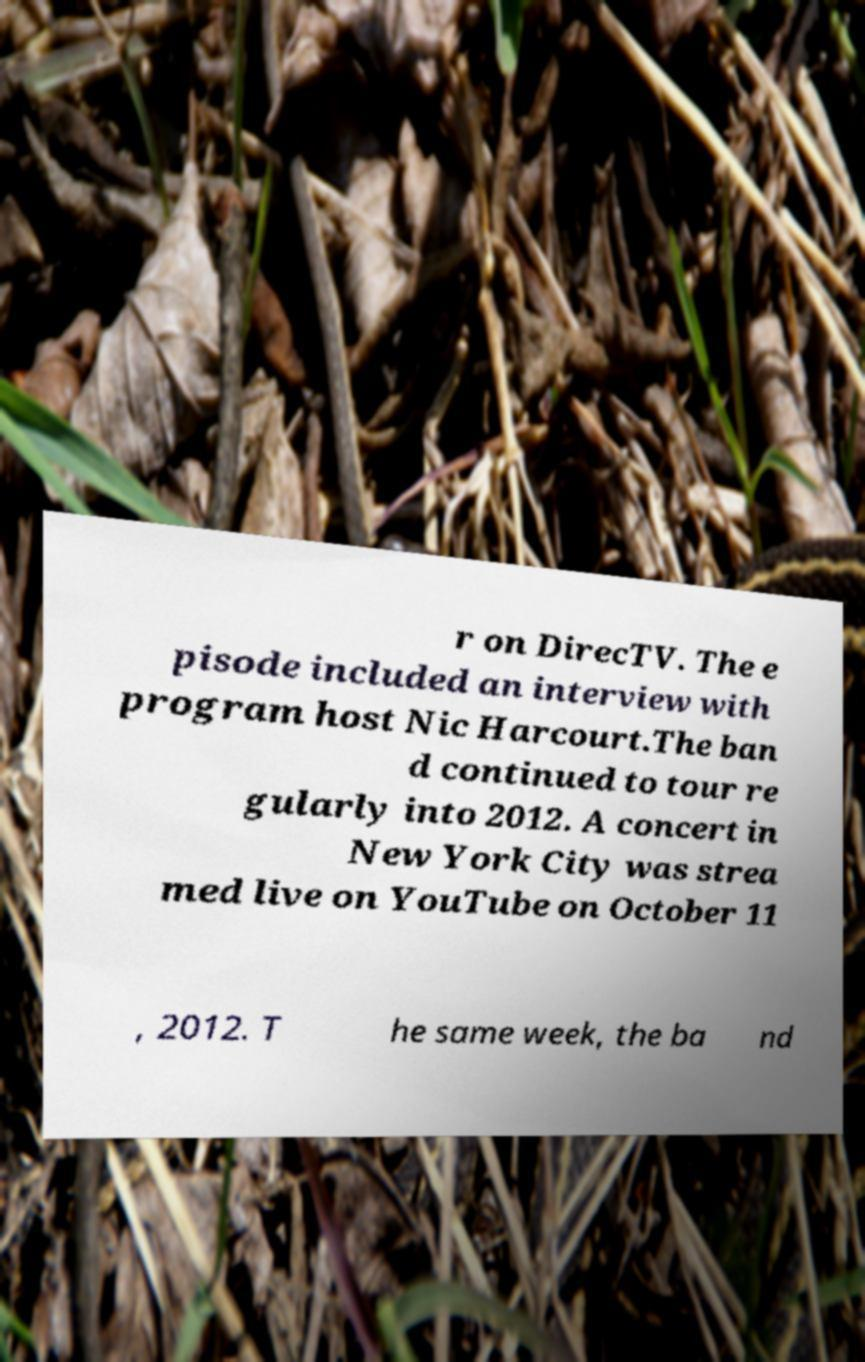What messages or text are displayed in this image? I need them in a readable, typed format. r on DirecTV. The e pisode included an interview with program host Nic Harcourt.The ban d continued to tour re gularly into 2012. A concert in New York City was strea med live on YouTube on October 11 , 2012. T he same week, the ba nd 